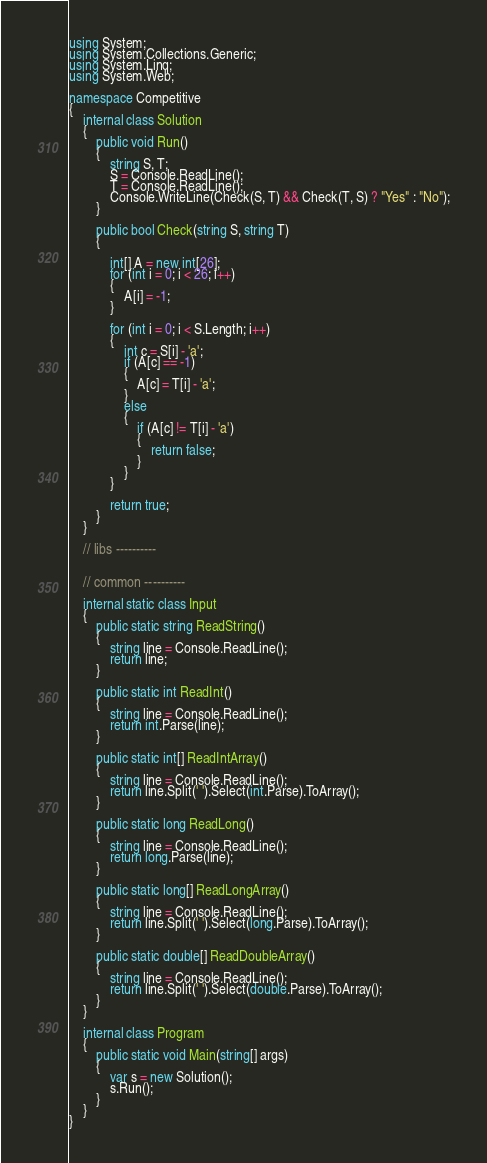Convert code to text. <code><loc_0><loc_0><loc_500><loc_500><_C#_>using System;
using System.Collections.Generic;
using System.Linq;
using System.Web;

namespace Competitive
{
    internal class Solution
    {
        public void Run()
        {
            string S, T;
            S = Console.ReadLine();
            T = Console.ReadLine();
            Console.WriteLine(Check(S, T) && Check(T, S) ? "Yes" : "No");
        }

        public bool Check(string S, string T)
        {

            int[] A = new int[26];
            for (int i = 0; i < 26; i++)
            {
                A[i] = -1;
            }

            for (int i = 0; i < S.Length; i++)
            {
                int c = S[i] - 'a';
                if (A[c] == -1)
                {
                    A[c] = T[i] - 'a';
                }
                else
                {
                    if (A[c] != T[i] - 'a')
                    {
                        return false;
                    }
                }
            }

            return true;
        }
    }

    // libs ----------
    

    // common ----------

    internal static class Input
    {
        public static string ReadString()
        {
            string line = Console.ReadLine();
            return line;
        }

        public static int ReadInt()
        {
            string line = Console.ReadLine();
            return int.Parse(line);
        }

        public static int[] ReadIntArray()
        {
            string line = Console.ReadLine();
            return line.Split(' ').Select(int.Parse).ToArray();            
        }

        public static long ReadLong()
        {
            string line = Console.ReadLine();
            return long.Parse(line);
        }

        public static long[] ReadLongArray()
        {
            string line = Console.ReadLine();
            return line.Split(' ').Select(long.Parse).ToArray();
        }

        public static double[] ReadDoubleArray()
        {
            string line = Console.ReadLine();
            return line.Split(' ').Select(double.Parse).ToArray();
        }
    }
    
    internal class Program
    {
        public static void Main(string[] args)
        {
            var s = new Solution();
            s.Run();
        }
    }
}</code> 